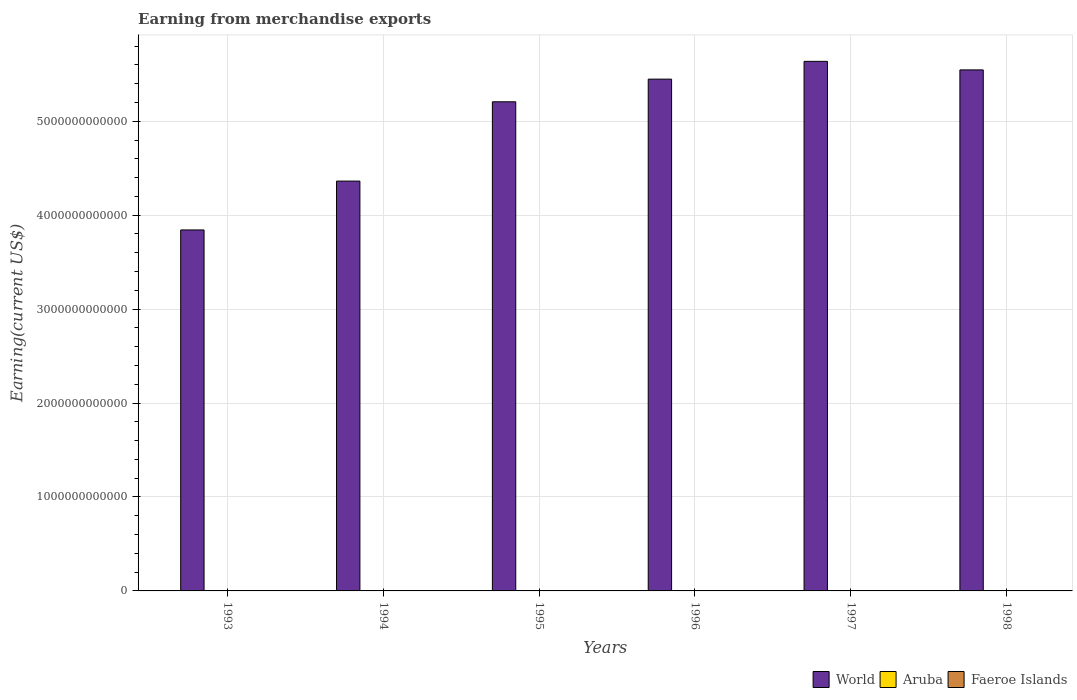How many different coloured bars are there?
Your answer should be very brief. 3. How many groups of bars are there?
Provide a succinct answer. 6. Are the number of bars per tick equal to the number of legend labels?
Your answer should be very brief. Yes. Are the number of bars on each tick of the X-axis equal?
Make the answer very short. Yes. How many bars are there on the 3rd tick from the left?
Your answer should be compact. 3. In how many cases, is the number of bars for a given year not equal to the number of legend labels?
Offer a very short reply. 0. What is the amount earned from merchandise exports in World in 1996?
Give a very brief answer. 5.45e+12. Across all years, what is the maximum amount earned from merchandise exports in Aruba?
Provide a short and direct response. 1.73e+09. Across all years, what is the minimum amount earned from merchandise exports in Faeroe Islands?
Give a very brief answer. 3.26e+08. In which year was the amount earned from merchandise exports in Faeroe Islands minimum?
Your answer should be very brief. 1994. What is the total amount earned from merchandise exports in World in the graph?
Your answer should be very brief. 3.00e+13. What is the difference between the amount earned from merchandise exports in World in 1994 and that in 1997?
Your answer should be very brief. -1.27e+12. What is the difference between the amount earned from merchandise exports in Aruba in 1993 and the amount earned from merchandise exports in World in 1997?
Offer a very short reply. -5.64e+12. What is the average amount earned from merchandise exports in World per year?
Offer a terse response. 5.01e+12. In the year 1994, what is the difference between the amount earned from merchandise exports in Faeroe Islands and amount earned from merchandise exports in Aruba?
Your response must be concise. -1.03e+09. In how many years, is the amount earned from merchandise exports in Faeroe Islands greater than 5600000000000 US$?
Make the answer very short. 0. What is the ratio of the amount earned from merchandise exports in Aruba in 1995 to that in 1996?
Provide a short and direct response. 0.78. What is the difference between the highest and the second highest amount earned from merchandise exports in Aruba?
Your answer should be compact. 8.44e+06. What is the difference between the highest and the lowest amount earned from merchandise exports in Aruba?
Your answer should be compact. 5.68e+08. What does the 3rd bar from the left in 1994 represents?
Provide a short and direct response. Faeroe Islands. What does the 3rd bar from the right in 1998 represents?
Your response must be concise. World. Is it the case that in every year, the sum of the amount earned from merchandise exports in Faeroe Islands and amount earned from merchandise exports in World is greater than the amount earned from merchandise exports in Aruba?
Make the answer very short. Yes. How many bars are there?
Keep it short and to the point. 18. What is the difference between two consecutive major ticks on the Y-axis?
Keep it short and to the point. 1.00e+12. Are the values on the major ticks of Y-axis written in scientific E-notation?
Offer a terse response. No. Does the graph contain any zero values?
Your response must be concise. No. Does the graph contain grids?
Keep it short and to the point. Yes. Where does the legend appear in the graph?
Make the answer very short. Bottom right. How many legend labels are there?
Offer a very short reply. 3. How are the legend labels stacked?
Give a very brief answer. Horizontal. What is the title of the graph?
Your answer should be compact. Earning from merchandise exports. Does "Qatar" appear as one of the legend labels in the graph?
Your answer should be compact. No. What is the label or title of the Y-axis?
Make the answer very short. Earning(current US$). What is the Earning(current US$) in World in 1993?
Provide a short and direct response. 3.84e+12. What is the Earning(current US$) of Aruba in 1993?
Ensure brevity in your answer.  1.21e+09. What is the Earning(current US$) of Faeroe Islands in 1993?
Offer a terse response. 3.27e+08. What is the Earning(current US$) of World in 1994?
Offer a terse response. 4.36e+12. What is the Earning(current US$) of Aruba in 1994?
Offer a terse response. 1.36e+09. What is the Earning(current US$) of Faeroe Islands in 1994?
Keep it short and to the point. 3.26e+08. What is the Earning(current US$) in World in 1995?
Offer a very short reply. 5.21e+12. What is the Earning(current US$) in Aruba in 1995?
Offer a terse response. 1.35e+09. What is the Earning(current US$) of Faeroe Islands in 1995?
Give a very brief answer. 3.62e+08. What is the Earning(current US$) of World in 1996?
Your answer should be compact. 5.45e+12. What is the Earning(current US$) of Aruba in 1996?
Give a very brief answer. 1.73e+09. What is the Earning(current US$) of Faeroe Islands in 1996?
Offer a terse response. 4.16e+08. What is the Earning(current US$) in World in 1997?
Your answer should be very brief. 5.64e+12. What is the Earning(current US$) of Aruba in 1997?
Make the answer very short. 1.72e+09. What is the Earning(current US$) of Faeroe Islands in 1997?
Offer a very short reply. 3.88e+08. What is the Earning(current US$) in World in 1998?
Keep it short and to the point. 5.55e+12. What is the Earning(current US$) of Aruba in 1998?
Offer a terse response. 1.16e+09. What is the Earning(current US$) in Faeroe Islands in 1998?
Provide a succinct answer. 4.37e+08. Across all years, what is the maximum Earning(current US$) in World?
Keep it short and to the point. 5.64e+12. Across all years, what is the maximum Earning(current US$) of Aruba?
Offer a very short reply. 1.73e+09. Across all years, what is the maximum Earning(current US$) in Faeroe Islands?
Offer a very short reply. 4.37e+08. Across all years, what is the minimum Earning(current US$) in World?
Offer a terse response. 3.84e+12. Across all years, what is the minimum Earning(current US$) of Aruba?
Offer a very short reply. 1.16e+09. Across all years, what is the minimum Earning(current US$) in Faeroe Islands?
Give a very brief answer. 3.26e+08. What is the total Earning(current US$) in World in the graph?
Give a very brief answer. 3.00e+13. What is the total Earning(current US$) of Aruba in the graph?
Ensure brevity in your answer.  8.54e+09. What is the total Earning(current US$) of Faeroe Islands in the graph?
Offer a very short reply. 2.26e+09. What is the difference between the Earning(current US$) in World in 1993 and that in 1994?
Keep it short and to the point. -5.20e+11. What is the difference between the Earning(current US$) in Aruba in 1993 and that in 1994?
Offer a terse response. -1.48e+08. What is the difference between the Earning(current US$) of Faeroe Islands in 1993 and that in 1994?
Offer a terse response. 1.00e+06. What is the difference between the Earning(current US$) of World in 1993 and that in 1995?
Your answer should be very brief. -1.36e+12. What is the difference between the Earning(current US$) in Aruba in 1993 and that in 1995?
Provide a succinct answer. -1.38e+08. What is the difference between the Earning(current US$) of Faeroe Islands in 1993 and that in 1995?
Provide a succinct answer. -3.50e+07. What is the difference between the Earning(current US$) of World in 1993 and that in 1996?
Provide a short and direct response. -1.61e+12. What is the difference between the Earning(current US$) of Aruba in 1993 and that in 1996?
Make the answer very short. -5.24e+08. What is the difference between the Earning(current US$) in Faeroe Islands in 1993 and that in 1996?
Provide a succinct answer. -8.90e+07. What is the difference between the Earning(current US$) in World in 1993 and that in 1997?
Ensure brevity in your answer.  -1.79e+12. What is the difference between the Earning(current US$) in Aruba in 1993 and that in 1997?
Offer a terse response. -5.16e+08. What is the difference between the Earning(current US$) of Faeroe Islands in 1993 and that in 1997?
Offer a terse response. -6.10e+07. What is the difference between the Earning(current US$) in World in 1993 and that in 1998?
Keep it short and to the point. -1.70e+12. What is the difference between the Earning(current US$) of Aruba in 1993 and that in 1998?
Your answer should be very brief. 4.40e+07. What is the difference between the Earning(current US$) in Faeroe Islands in 1993 and that in 1998?
Make the answer very short. -1.10e+08. What is the difference between the Earning(current US$) of World in 1994 and that in 1995?
Offer a terse response. -8.44e+11. What is the difference between the Earning(current US$) in Aruba in 1994 and that in 1995?
Your answer should be very brief. 9.89e+06. What is the difference between the Earning(current US$) in Faeroe Islands in 1994 and that in 1995?
Your answer should be compact. -3.60e+07. What is the difference between the Earning(current US$) of World in 1994 and that in 1996?
Give a very brief answer. -1.09e+12. What is the difference between the Earning(current US$) in Aruba in 1994 and that in 1996?
Provide a succinct answer. -3.76e+08. What is the difference between the Earning(current US$) of Faeroe Islands in 1994 and that in 1996?
Ensure brevity in your answer.  -9.00e+07. What is the difference between the Earning(current US$) of World in 1994 and that in 1997?
Offer a terse response. -1.27e+12. What is the difference between the Earning(current US$) of Aruba in 1994 and that in 1997?
Provide a succinct answer. -3.68e+08. What is the difference between the Earning(current US$) in Faeroe Islands in 1994 and that in 1997?
Keep it short and to the point. -6.20e+07. What is the difference between the Earning(current US$) of World in 1994 and that in 1998?
Provide a short and direct response. -1.18e+12. What is the difference between the Earning(current US$) in Aruba in 1994 and that in 1998?
Give a very brief answer. 1.92e+08. What is the difference between the Earning(current US$) in Faeroe Islands in 1994 and that in 1998?
Provide a short and direct response. -1.11e+08. What is the difference between the Earning(current US$) of World in 1995 and that in 1996?
Your response must be concise. -2.41e+11. What is the difference between the Earning(current US$) in Aruba in 1995 and that in 1996?
Provide a succinct answer. -3.86e+08. What is the difference between the Earning(current US$) of Faeroe Islands in 1995 and that in 1996?
Offer a very short reply. -5.40e+07. What is the difference between the Earning(current US$) of World in 1995 and that in 1997?
Make the answer very short. -4.30e+11. What is the difference between the Earning(current US$) of Aruba in 1995 and that in 1997?
Offer a very short reply. -3.78e+08. What is the difference between the Earning(current US$) in Faeroe Islands in 1995 and that in 1997?
Give a very brief answer. -2.60e+07. What is the difference between the Earning(current US$) of World in 1995 and that in 1998?
Make the answer very short. -3.39e+11. What is the difference between the Earning(current US$) of Aruba in 1995 and that in 1998?
Your answer should be compact. 1.82e+08. What is the difference between the Earning(current US$) of Faeroe Islands in 1995 and that in 1998?
Your response must be concise. -7.50e+07. What is the difference between the Earning(current US$) in World in 1996 and that in 1997?
Provide a short and direct response. -1.89e+11. What is the difference between the Earning(current US$) in Aruba in 1996 and that in 1997?
Provide a short and direct response. 8.44e+06. What is the difference between the Earning(current US$) in Faeroe Islands in 1996 and that in 1997?
Provide a succinct answer. 2.80e+07. What is the difference between the Earning(current US$) in World in 1996 and that in 1998?
Give a very brief answer. -9.83e+1. What is the difference between the Earning(current US$) of Aruba in 1996 and that in 1998?
Offer a terse response. 5.68e+08. What is the difference between the Earning(current US$) of Faeroe Islands in 1996 and that in 1998?
Your answer should be compact. -2.10e+07. What is the difference between the Earning(current US$) in World in 1997 and that in 1998?
Your answer should be compact. 9.09e+1. What is the difference between the Earning(current US$) in Aruba in 1997 and that in 1998?
Make the answer very short. 5.60e+08. What is the difference between the Earning(current US$) of Faeroe Islands in 1997 and that in 1998?
Provide a succinct answer. -4.90e+07. What is the difference between the Earning(current US$) of World in 1993 and the Earning(current US$) of Aruba in 1994?
Offer a terse response. 3.84e+12. What is the difference between the Earning(current US$) of World in 1993 and the Earning(current US$) of Faeroe Islands in 1994?
Offer a terse response. 3.84e+12. What is the difference between the Earning(current US$) of Aruba in 1993 and the Earning(current US$) of Faeroe Islands in 1994?
Keep it short and to the point. 8.83e+08. What is the difference between the Earning(current US$) in World in 1993 and the Earning(current US$) in Aruba in 1995?
Keep it short and to the point. 3.84e+12. What is the difference between the Earning(current US$) of World in 1993 and the Earning(current US$) of Faeroe Islands in 1995?
Ensure brevity in your answer.  3.84e+12. What is the difference between the Earning(current US$) in Aruba in 1993 and the Earning(current US$) in Faeroe Islands in 1995?
Offer a terse response. 8.47e+08. What is the difference between the Earning(current US$) in World in 1993 and the Earning(current US$) in Aruba in 1996?
Give a very brief answer. 3.84e+12. What is the difference between the Earning(current US$) in World in 1993 and the Earning(current US$) in Faeroe Islands in 1996?
Offer a terse response. 3.84e+12. What is the difference between the Earning(current US$) in Aruba in 1993 and the Earning(current US$) in Faeroe Islands in 1996?
Your answer should be compact. 7.93e+08. What is the difference between the Earning(current US$) of World in 1993 and the Earning(current US$) of Aruba in 1997?
Offer a very short reply. 3.84e+12. What is the difference between the Earning(current US$) of World in 1993 and the Earning(current US$) of Faeroe Islands in 1997?
Provide a short and direct response. 3.84e+12. What is the difference between the Earning(current US$) of Aruba in 1993 and the Earning(current US$) of Faeroe Islands in 1997?
Provide a succinct answer. 8.21e+08. What is the difference between the Earning(current US$) of World in 1993 and the Earning(current US$) of Aruba in 1998?
Provide a short and direct response. 3.84e+12. What is the difference between the Earning(current US$) of World in 1993 and the Earning(current US$) of Faeroe Islands in 1998?
Provide a succinct answer. 3.84e+12. What is the difference between the Earning(current US$) in Aruba in 1993 and the Earning(current US$) in Faeroe Islands in 1998?
Keep it short and to the point. 7.72e+08. What is the difference between the Earning(current US$) of World in 1994 and the Earning(current US$) of Aruba in 1995?
Your answer should be compact. 4.36e+12. What is the difference between the Earning(current US$) of World in 1994 and the Earning(current US$) of Faeroe Islands in 1995?
Your response must be concise. 4.36e+12. What is the difference between the Earning(current US$) in Aruba in 1994 and the Earning(current US$) in Faeroe Islands in 1995?
Your answer should be compact. 9.95e+08. What is the difference between the Earning(current US$) in World in 1994 and the Earning(current US$) in Aruba in 1996?
Provide a succinct answer. 4.36e+12. What is the difference between the Earning(current US$) of World in 1994 and the Earning(current US$) of Faeroe Islands in 1996?
Offer a very short reply. 4.36e+12. What is the difference between the Earning(current US$) in Aruba in 1994 and the Earning(current US$) in Faeroe Islands in 1996?
Give a very brief answer. 9.41e+08. What is the difference between the Earning(current US$) in World in 1994 and the Earning(current US$) in Aruba in 1997?
Your answer should be very brief. 4.36e+12. What is the difference between the Earning(current US$) in World in 1994 and the Earning(current US$) in Faeroe Islands in 1997?
Ensure brevity in your answer.  4.36e+12. What is the difference between the Earning(current US$) in Aruba in 1994 and the Earning(current US$) in Faeroe Islands in 1997?
Provide a short and direct response. 9.69e+08. What is the difference between the Earning(current US$) in World in 1994 and the Earning(current US$) in Aruba in 1998?
Make the answer very short. 4.36e+12. What is the difference between the Earning(current US$) of World in 1994 and the Earning(current US$) of Faeroe Islands in 1998?
Keep it short and to the point. 4.36e+12. What is the difference between the Earning(current US$) of Aruba in 1994 and the Earning(current US$) of Faeroe Islands in 1998?
Offer a very short reply. 9.20e+08. What is the difference between the Earning(current US$) of World in 1995 and the Earning(current US$) of Aruba in 1996?
Ensure brevity in your answer.  5.21e+12. What is the difference between the Earning(current US$) of World in 1995 and the Earning(current US$) of Faeroe Islands in 1996?
Your answer should be very brief. 5.21e+12. What is the difference between the Earning(current US$) in Aruba in 1995 and the Earning(current US$) in Faeroe Islands in 1996?
Your answer should be very brief. 9.31e+08. What is the difference between the Earning(current US$) of World in 1995 and the Earning(current US$) of Aruba in 1997?
Your answer should be very brief. 5.21e+12. What is the difference between the Earning(current US$) of World in 1995 and the Earning(current US$) of Faeroe Islands in 1997?
Your response must be concise. 5.21e+12. What is the difference between the Earning(current US$) of Aruba in 1995 and the Earning(current US$) of Faeroe Islands in 1997?
Your answer should be very brief. 9.59e+08. What is the difference between the Earning(current US$) of World in 1995 and the Earning(current US$) of Aruba in 1998?
Ensure brevity in your answer.  5.21e+12. What is the difference between the Earning(current US$) in World in 1995 and the Earning(current US$) in Faeroe Islands in 1998?
Make the answer very short. 5.21e+12. What is the difference between the Earning(current US$) of Aruba in 1995 and the Earning(current US$) of Faeroe Islands in 1998?
Give a very brief answer. 9.10e+08. What is the difference between the Earning(current US$) of World in 1996 and the Earning(current US$) of Aruba in 1997?
Keep it short and to the point. 5.45e+12. What is the difference between the Earning(current US$) of World in 1996 and the Earning(current US$) of Faeroe Islands in 1997?
Provide a succinct answer. 5.45e+12. What is the difference between the Earning(current US$) in Aruba in 1996 and the Earning(current US$) in Faeroe Islands in 1997?
Ensure brevity in your answer.  1.35e+09. What is the difference between the Earning(current US$) of World in 1996 and the Earning(current US$) of Aruba in 1998?
Provide a succinct answer. 5.45e+12. What is the difference between the Earning(current US$) of World in 1996 and the Earning(current US$) of Faeroe Islands in 1998?
Provide a succinct answer. 5.45e+12. What is the difference between the Earning(current US$) in Aruba in 1996 and the Earning(current US$) in Faeroe Islands in 1998?
Make the answer very short. 1.30e+09. What is the difference between the Earning(current US$) of World in 1997 and the Earning(current US$) of Aruba in 1998?
Provide a short and direct response. 5.64e+12. What is the difference between the Earning(current US$) of World in 1997 and the Earning(current US$) of Faeroe Islands in 1998?
Keep it short and to the point. 5.64e+12. What is the difference between the Earning(current US$) of Aruba in 1997 and the Earning(current US$) of Faeroe Islands in 1998?
Your response must be concise. 1.29e+09. What is the average Earning(current US$) in World per year?
Offer a terse response. 5.01e+12. What is the average Earning(current US$) in Aruba per year?
Your answer should be very brief. 1.42e+09. What is the average Earning(current US$) in Faeroe Islands per year?
Your answer should be very brief. 3.76e+08. In the year 1993, what is the difference between the Earning(current US$) in World and Earning(current US$) in Aruba?
Your response must be concise. 3.84e+12. In the year 1993, what is the difference between the Earning(current US$) of World and Earning(current US$) of Faeroe Islands?
Ensure brevity in your answer.  3.84e+12. In the year 1993, what is the difference between the Earning(current US$) of Aruba and Earning(current US$) of Faeroe Islands?
Provide a short and direct response. 8.82e+08. In the year 1994, what is the difference between the Earning(current US$) in World and Earning(current US$) in Aruba?
Your answer should be very brief. 4.36e+12. In the year 1994, what is the difference between the Earning(current US$) in World and Earning(current US$) in Faeroe Islands?
Offer a very short reply. 4.36e+12. In the year 1994, what is the difference between the Earning(current US$) in Aruba and Earning(current US$) in Faeroe Islands?
Keep it short and to the point. 1.03e+09. In the year 1995, what is the difference between the Earning(current US$) of World and Earning(current US$) of Aruba?
Your response must be concise. 5.21e+12. In the year 1995, what is the difference between the Earning(current US$) in World and Earning(current US$) in Faeroe Islands?
Make the answer very short. 5.21e+12. In the year 1995, what is the difference between the Earning(current US$) in Aruba and Earning(current US$) in Faeroe Islands?
Your response must be concise. 9.85e+08. In the year 1996, what is the difference between the Earning(current US$) in World and Earning(current US$) in Aruba?
Your answer should be compact. 5.45e+12. In the year 1996, what is the difference between the Earning(current US$) in World and Earning(current US$) in Faeroe Islands?
Your answer should be very brief. 5.45e+12. In the year 1996, what is the difference between the Earning(current US$) in Aruba and Earning(current US$) in Faeroe Islands?
Your response must be concise. 1.32e+09. In the year 1997, what is the difference between the Earning(current US$) in World and Earning(current US$) in Aruba?
Make the answer very short. 5.64e+12. In the year 1997, what is the difference between the Earning(current US$) of World and Earning(current US$) of Faeroe Islands?
Provide a short and direct response. 5.64e+12. In the year 1997, what is the difference between the Earning(current US$) in Aruba and Earning(current US$) in Faeroe Islands?
Offer a terse response. 1.34e+09. In the year 1998, what is the difference between the Earning(current US$) in World and Earning(current US$) in Aruba?
Provide a short and direct response. 5.55e+12. In the year 1998, what is the difference between the Earning(current US$) in World and Earning(current US$) in Faeroe Islands?
Offer a terse response. 5.55e+12. In the year 1998, what is the difference between the Earning(current US$) of Aruba and Earning(current US$) of Faeroe Islands?
Your response must be concise. 7.28e+08. What is the ratio of the Earning(current US$) of World in 1993 to that in 1994?
Give a very brief answer. 0.88. What is the ratio of the Earning(current US$) in Aruba in 1993 to that in 1994?
Your answer should be very brief. 0.89. What is the ratio of the Earning(current US$) of World in 1993 to that in 1995?
Keep it short and to the point. 0.74. What is the ratio of the Earning(current US$) of Aruba in 1993 to that in 1995?
Your answer should be compact. 0.9. What is the ratio of the Earning(current US$) of Faeroe Islands in 1993 to that in 1995?
Your answer should be compact. 0.9. What is the ratio of the Earning(current US$) of World in 1993 to that in 1996?
Your answer should be compact. 0.71. What is the ratio of the Earning(current US$) in Aruba in 1993 to that in 1996?
Your answer should be compact. 0.7. What is the ratio of the Earning(current US$) of Faeroe Islands in 1993 to that in 1996?
Provide a short and direct response. 0.79. What is the ratio of the Earning(current US$) of World in 1993 to that in 1997?
Your answer should be compact. 0.68. What is the ratio of the Earning(current US$) of Aruba in 1993 to that in 1997?
Keep it short and to the point. 0.7. What is the ratio of the Earning(current US$) in Faeroe Islands in 1993 to that in 1997?
Your response must be concise. 0.84. What is the ratio of the Earning(current US$) of World in 1993 to that in 1998?
Provide a short and direct response. 0.69. What is the ratio of the Earning(current US$) in Aruba in 1993 to that in 1998?
Ensure brevity in your answer.  1.04. What is the ratio of the Earning(current US$) in Faeroe Islands in 1993 to that in 1998?
Give a very brief answer. 0.75. What is the ratio of the Earning(current US$) of World in 1994 to that in 1995?
Provide a succinct answer. 0.84. What is the ratio of the Earning(current US$) of Aruba in 1994 to that in 1995?
Offer a terse response. 1.01. What is the ratio of the Earning(current US$) in Faeroe Islands in 1994 to that in 1995?
Your answer should be very brief. 0.9. What is the ratio of the Earning(current US$) in World in 1994 to that in 1996?
Offer a very short reply. 0.8. What is the ratio of the Earning(current US$) in Aruba in 1994 to that in 1996?
Your response must be concise. 0.78. What is the ratio of the Earning(current US$) in Faeroe Islands in 1994 to that in 1996?
Offer a very short reply. 0.78. What is the ratio of the Earning(current US$) in World in 1994 to that in 1997?
Provide a succinct answer. 0.77. What is the ratio of the Earning(current US$) in Aruba in 1994 to that in 1997?
Ensure brevity in your answer.  0.79. What is the ratio of the Earning(current US$) of Faeroe Islands in 1994 to that in 1997?
Make the answer very short. 0.84. What is the ratio of the Earning(current US$) in World in 1994 to that in 1998?
Provide a short and direct response. 0.79. What is the ratio of the Earning(current US$) in Aruba in 1994 to that in 1998?
Offer a very short reply. 1.17. What is the ratio of the Earning(current US$) in Faeroe Islands in 1994 to that in 1998?
Keep it short and to the point. 0.75. What is the ratio of the Earning(current US$) of World in 1995 to that in 1996?
Your answer should be very brief. 0.96. What is the ratio of the Earning(current US$) of Aruba in 1995 to that in 1996?
Give a very brief answer. 0.78. What is the ratio of the Earning(current US$) in Faeroe Islands in 1995 to that in 1996?
Keep it short and to the point. 0.87. What is the ratio of the Earning(current US$) of World in 1995 to that in 1997?
Your answer should be very brief. 0.92. What is the ratio of the Earning(current US$) in Aruba in 1995 to that in 1997?
Provide a short and direct response. 0.78. What is the ratio of the Earning(current US$) of Faeroe Islands in 1995 to that in 1997?
Your answer should be compact. 0.93. What is the ratio of the Earning(current US$) in World in 1995 to that in 1998?
Your answer should be very brief. 0.94. What is the ratio of the Earning(current US$) in Aruba in 1995 to that in 1998?
Provide a short and direct response. 1.16. What is the ratio of the Earning(current US$) of Faeroe Islands in 1995 to that in 1998?
Your answer should be compact. 0.83. What is the ratio of the Earning(current US$) of World in 1996 to that in 1997?
Offer a very short reply. 0.97. What is the ratio of the Earning(current US$) of Faeroe Islands in 1996 to that in 1997?
Your answer should be very brief. 1.07. What is the ratio of the Earning(current US$) in World in 1996 to that in 1998?
Make the answer very short. 0.98. What is the ratio of the Earning(current US$) of Aruba in 1996 to that in 1998?
Your answer should be compact. 1.49. What is the ratio of the Earning(current US$) in Faeroe Islands in 1996 to that in 1998?
Offer a very short reply. 0.95. What is the ratio of the Earning(current US$) of World in 1997 to that in 1998?
Provide a short and direct response. 1.02. What is the ratio of the Earning(current US$) in Aruba in 1997 to that in 1998?
Your answer should be compact. 1.48. What is the ratio of the Earning(current US$) of Faeroe Islands in 1997 to that in 1998?
Provide a short and direct response. 0.89. What is the difference between the highest and the second highest Earning(current US$) of World?
Provide a succinct answer. 9.09e+1. What is the difference between the highest and the second highest Earning(current US$) of Aruba?
Your response must be concise. 8.44e+06. What is the difference between the highest and the second highest Earning(current US$) in Faeroe Islands?
Your response must be concise. 2.10e+07. What is the difference between the highest and the lowest Earning(current US$) in World?
Your response must be concise. 1.79e+12. What is the difference between the highest and the lowest Earning(current US$) in Aruba?
Ensure brevity in your answer.  5.68e+08. What is the difference between the highest and the lowest Earning(current US$) of Faeroe Islands?
Give a very brief answer. 1.11e+08. 